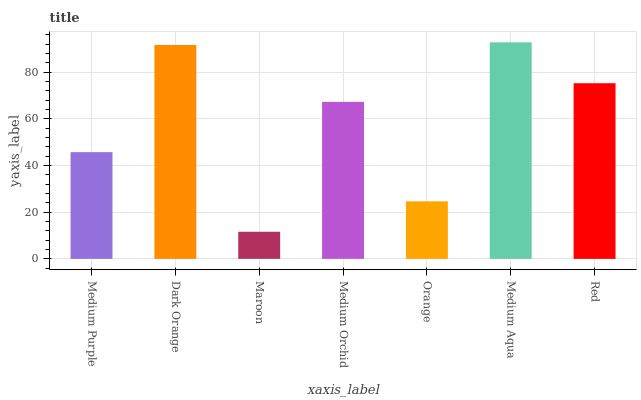Is Maroon the minimum?
Answer yes or no. Yes. Is Medium Aqua the maximum?
Answer yes or no. Yes. Is Dark Orange the minimum?
Answer yes or no. No. Is Dark Orange the maximum?
Answer yes or no. No. Is Dark Orange greater than Medium Purple?
Answer yes or no. Yes. Is Medium Purple less than Dark Orange?
Answer yes or no. Yes. Is Medium Purple greater than Dark Orange?
Answer yes or no. No. Is Dark Orange less than Medium Purple?
Answer yes or no. No. Is Medium Orchid the high median?
Answer yes or no. Yes. Is Medium Orchid the low median?
Answer yes or no. Yes. Is Medium Purple the high median?
Answer yes or no. No. Is Orange the low median?
Answer yes or no. No. 